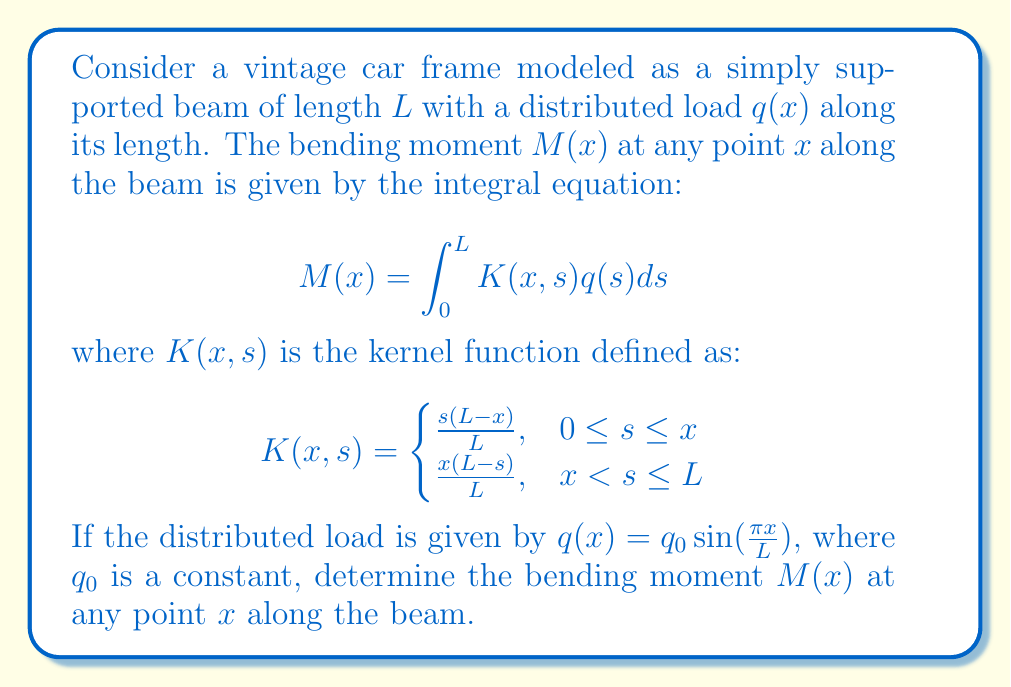Help me with this question. To solve this problem, we need to follow these steps:

1) First, we substitute the given load function into the integral equation:

   $$M(x) = \int_0^L K(x,s)q_0 \sin(\frac{\pi s}{L})ds$$

2) We split the integral into two parts based on the piecewise definition of $K(x,s)$:

   $$M(x) = \int_0^x \frac{s(L-x)}{L}q_0 \sin(\frac{\pi s}{L})ds + \int_x^L \frac{x(L-s)}{L}q_0 \sin(\frac{\pi s}{L})ds$$

3) Let's solve the first integral:

   $$I_1 = \frac{q_0(L-x)}{L}\int_0^x s\sin(\frac{\pi s}{L})ds$$

   Using integration by parts, we get:

   $$I_1 = \frac{q_0(L-x)}{L}[\frac{-L^2}{\pi^2}\sin(\frac{\pi s}{L}) + \frac{Ls}{\pi}\cos(\frac{\pi s}{L})]_0^x$$

   $$I_1 = \frac{q_0(L-x)}{L}[-\frac{L^2}{\pi^2}\sin(\frac{\pi x}{L}) + \frac{Lx}{\pi}\cos(\frac{\pi x}{L}) + \frac{L^2}{\pi^2}]$$

4) Now, let's solve the second integral:

   $$I_2 = \frac{q_0x}{L}\int_x^L (L-s)\sin(\frac{\pi s}{L})ds$$

   Again, using integration by parts:

   $$I_2 = \frac{q_0x}{L}[L\frac{-L}{\pi}\cos(\frac{\pi s}{L}) - \frac{L^2}{\pi^2}\sin(\frac{\pi s}{L}) + s\frac{L}{\pi}\cos(\frac{\pi s}{L})]_x^L$$

   $$I_2 = \frac{q_0x}{L}[-\frac{L^2}{\pi} + \frac{L^2}{\pi}\cos(\frac{\pi x}{L}) + \frac{L^2}{\pi^2}\sin(\frac{\pi x}{L})]$$

5) The total bending moment is the sum of $I_1$ and $I_2$:

   $$M(x) = I_1 + I_2$$

6) After simplification, we get:

   $$M(x) = \frac{q_0L^2}{\pi^2}[1 - \cos(\frac{\pi x}{L})]$$

This is the expression for the bending moment at any point $x$ along the beam.
Answer: $$M(x) = \frac{q_0L^2}{\pi^2}[1 - \cos(\frac{\pi x}{L})]$$ 